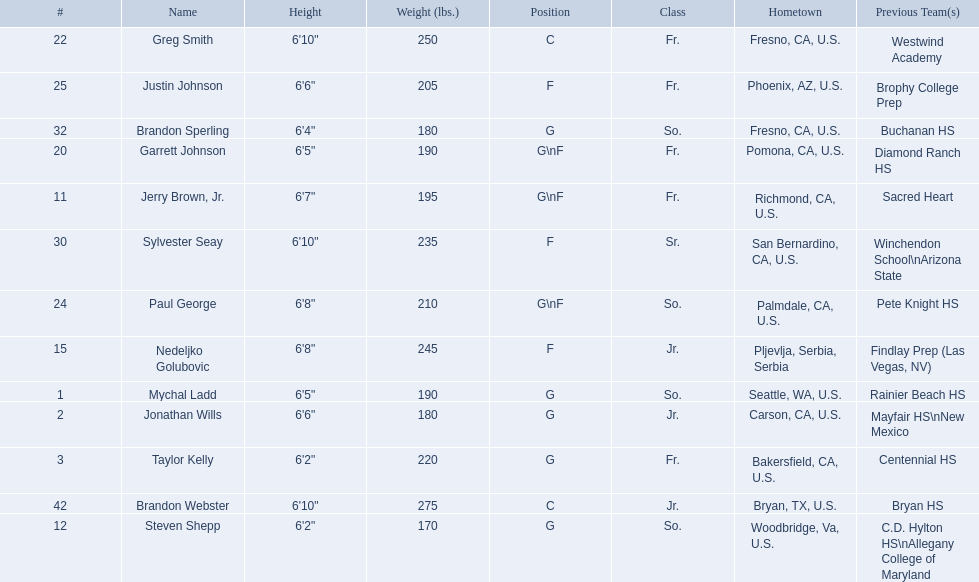What are the names of the basketball team players? Mychal Ladd, Jonathan Wills, Taylor Kelly, Jerry Brown, Jr., Steven Shepp, Nedeljko Golubovic, Garrett Johnson, Greg Smith, Paul George, Justin Johnson, Sylvester Seay, Brandon Sperling, Brandon Webster. Of these identify paul george and greg smith Greg Smith, Paul George. What are their corresponding heights? 6'10", 6'8". To who does the larger height correspond to? Greg Smith. 